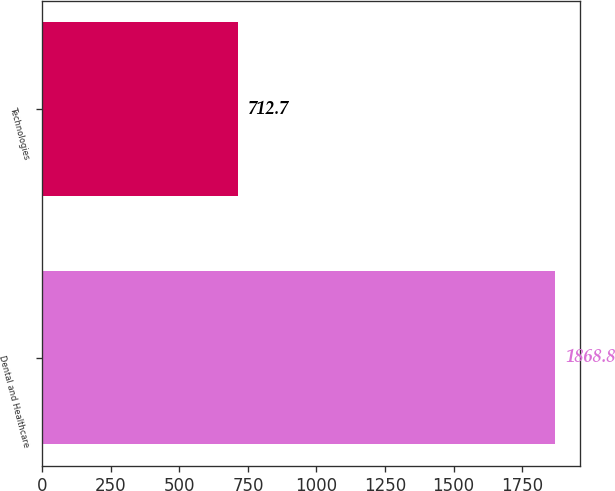Convert chart. <chart><loc_0><loc_0><loc_500><loc_500><bar_chart><fcel>Dental and Healthcare<fcel>Technologies<nl><fcel>1868.8<fcel>712.7<nl></chart> 